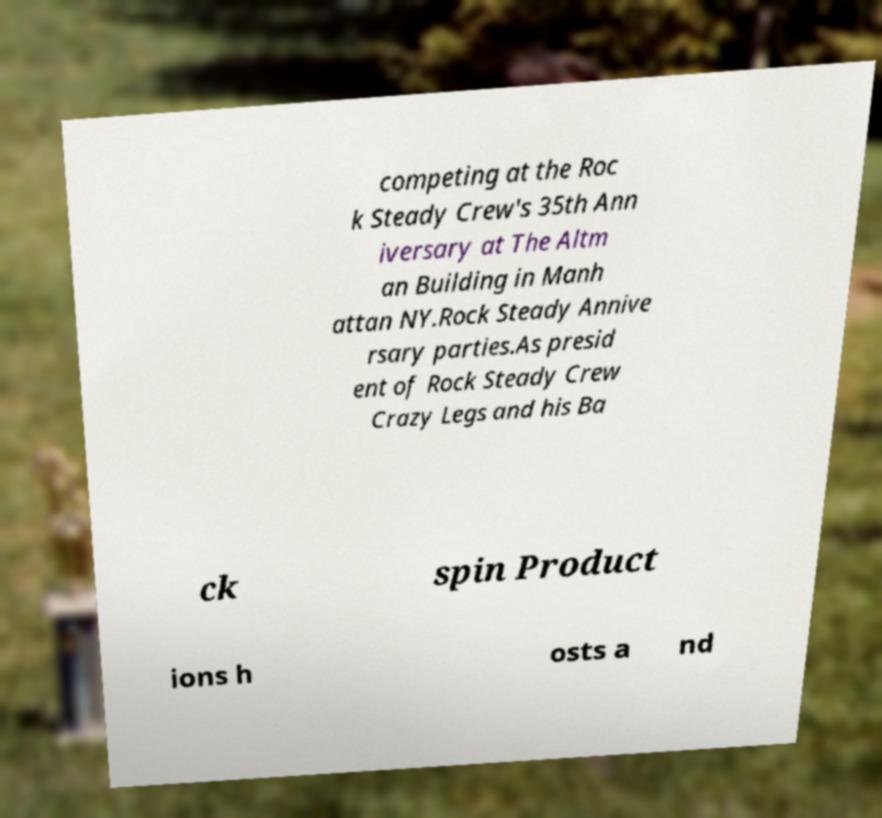Please read and relay the text visible in this image. What does it say? competing at the Roc k Steady Crew's 35th Ann iversary at The Altm an Building in Manh attan NY.Rock Steady Annive rsary parties.As presid ent of Rock Steady Crew Crazy Legs and his Ba ck spin Product ions h osts a nd 